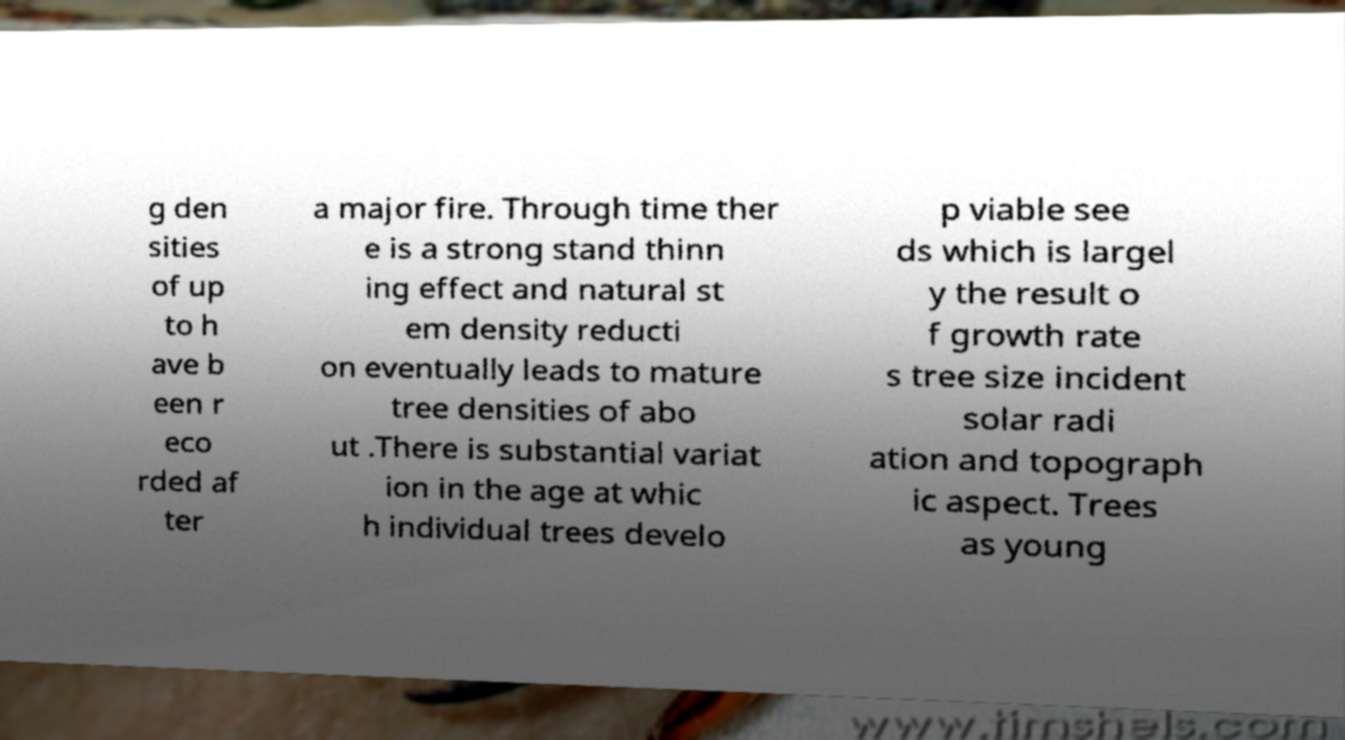Could you extract and type out the text from this image? g den sities of up to h ave b een r eco rded af ter a major fire. Through time ther e is a strong stand thinn ing effect and natural st em density reducti on eventually leads to mature tree densities of abo ut .There is substantial variat ion in the age at whic h individual trees develo p viable see ds which is largel y the result o f growth rate s tree size incident solar radi ation and topograph ic aspect. Trees as young 